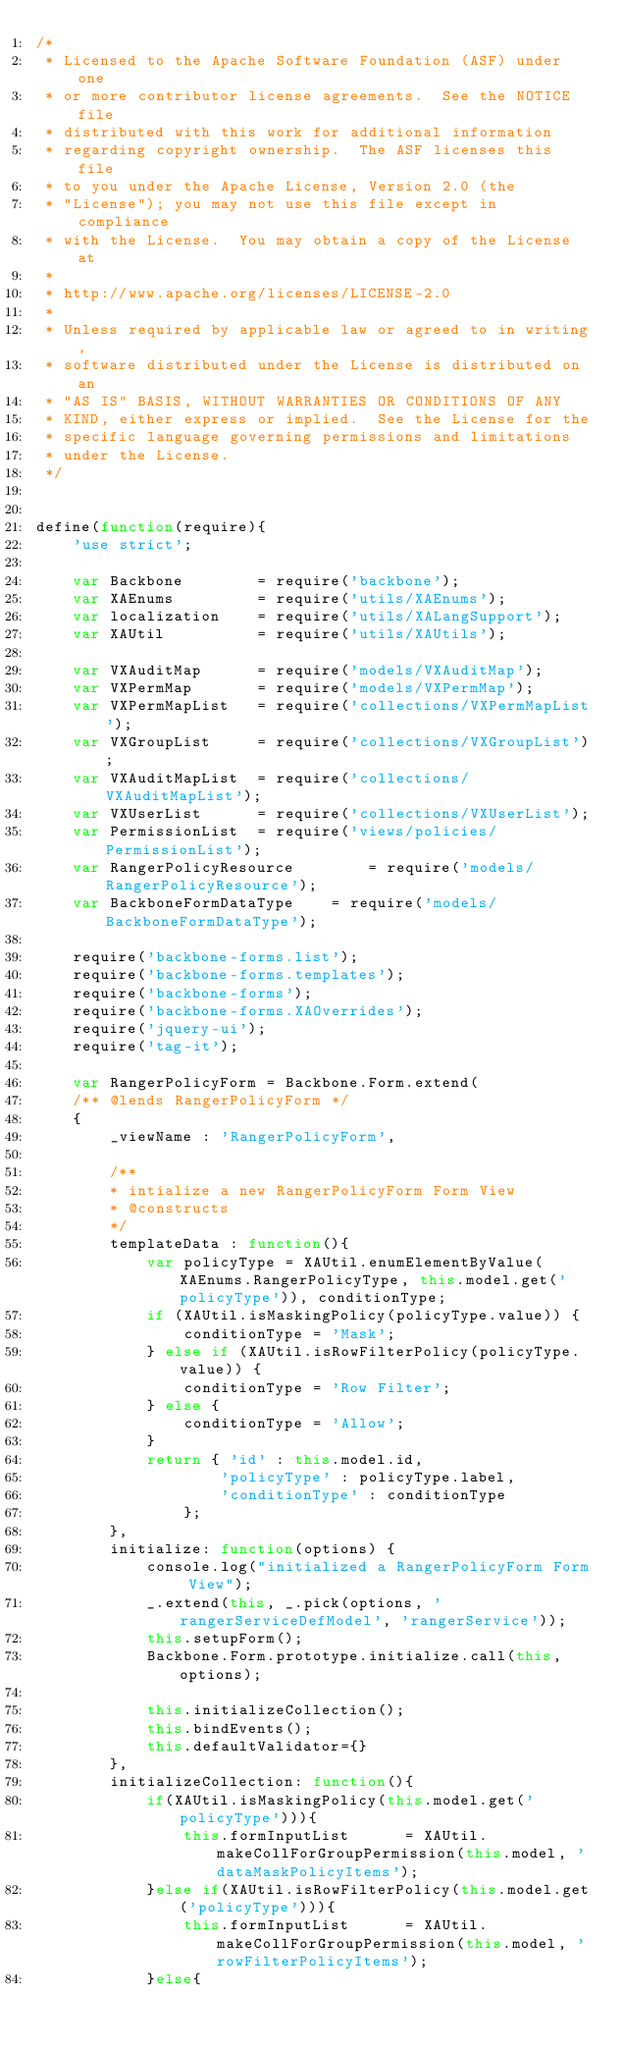Convert code to text. <code><loc_0><loc_0><loc_500><loc_500><_JavaScript_>/*
 * Licensed to the Apache Software Foundation (ASF) under one
 * or more contributor license agreements.  See the NOTICE file
 * distributed with this work for additional information
 * regarding copyright ownership.  The ASF licenses this file
 * to you under the Apache License, Version 2.0 (the
 * "License"); you may not use this file except in compliance
 * with the License.  You may obtain a copy of the License at
 * 
 * http://www.apache.org/licenses/LICENSE-2.0
 * 
 * Unless required by applicable law or agreed to in writing,
 * software distributed under the License is distributed on an
 * "AS IS" BASIS, WITHOUT WARRANTIES OR CONDITIONS OF ANY
 * KIND, either express or implied.  See the License for the
 * specific language governing permissions and limitations
 * under the License.
 */

 
define(function(require){
    'use strict';

	var Backbone		= require('backbone');
	var XAEnums			= require('utils/XAEnums');
	var localization	= require('utils/XALangSupport');
	var XAUtil			= require('utils/XAUtils');
    
	var VXAuditMap		= require('models/VXAuditMap');
	var VXPermMap		= require('models/VXPermMap');
	var VXPermMapList	= require('collections/VXPermMapList');
	var VXGroupList		= require('collections/VXGroupList');
	var VXAuditMapList	= require('collections/VXAuditMapList');
	var VXUserList		= require('collections/VXUserList');
	var PermissionList 	= require('views/policies/PermissionList');
	var RangerPolicyResource		= require('models/RangerPolicyResource');
	var BackboneFormDataType	= require('models/BackboneFormDataType');

	require('backbone-forms.list');
	require('backbone-forms.templates');
	require('backbone-forms');
	require('backbone-forms.XAOverrides');
	require('jquery-ui');
	require('tag-it');

	var RangerPolicyForm = Backbone.Form.extend(
	/** @lends RangerPolicyForm */
	{
		_viewName : 'RangerPolicyForm',

    	/**
		* intialize a new RangerPolicyForm Form View 
		* @constructs
		*/
		templateData : function(){
			var policyType = XAUtil.enumElementByValue(XAEnums.RangerPolicyType, this.model.get('policyType')), conditionType;
			if (XAUtil.isMaskingPolicy(policyType.value)) {
				conditionType = 'Mask';
			} else if (XAUtil.isRowFilterPolicy(policyType.value)) {
				conditionType = 'Row Filter';
			} else {
				conditionType = 'Allow';
			}
			return { 'id' : this.model.id,
					'policyType' : policyType.label,
					'conditionType' : conditionType
				};
		},
		initialize: function(options) {
			console.log("initialized a RangerPolicyForm Form View");
			_.extend(this, _.pick(options, 'rangerServiceDefModel', 'rangerService'));
    		this.setupForm();
    		Backbone.Form.prototype.initialize.call(this, options);

			this.initializeCollection();
			this.bindEvents();
			this.defaultValidator={}
		},
		initializeCollection: function(){
			if(XAUtil.isMaskingPolicy(this.model.get('policyType'))){
				this.formInputList 		= XAUtil.makeCollForGroupPermission(this.model, 'dataMaskPolicyItems');
			}else if(XAUtil.isRowFilterPolicy(this.model.get('policyType'))){
				this.formInputList 		= XAUtil.makeCollForGroupPermission(this.model, 'rowFilterPolicyItems');
			}else{</code> 